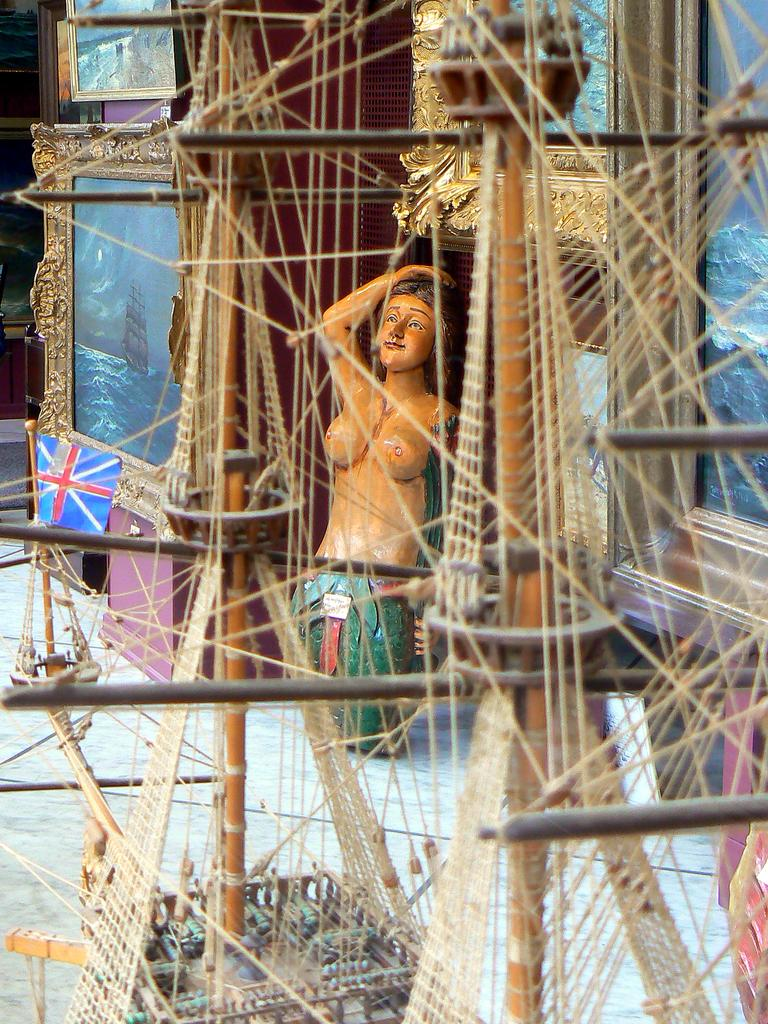What is the main subject of the image? The main subject of the image is a miniature boat. Can you describe the boat's appearance? The boat is cream-colored. What else can be seen in the background of the image? There is a statue of a person in the background. What other object is present in the image? There is a flag in the image. How many frames are visible in the image? There are many frames in the image. Is there a record player visible in the image? No, there is no record player present in the image. 